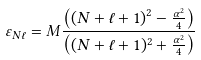Convert formula to latex. <formula><loc_0><loc_0><loc_500><loc_500>\varepsilon _ { N \ell } = M \frac { \left ( { \left ( { N + \ell + 1 } \right ) ^ { 2 } - \frac { \alpha ^ { 2 } } { 4 } } \right ) } { \left ( { ( N + \ell + 1 ) ^ { 2 } + \frac { \alpha ^ { 2 } } { 4 } } \right ) }</formula> 